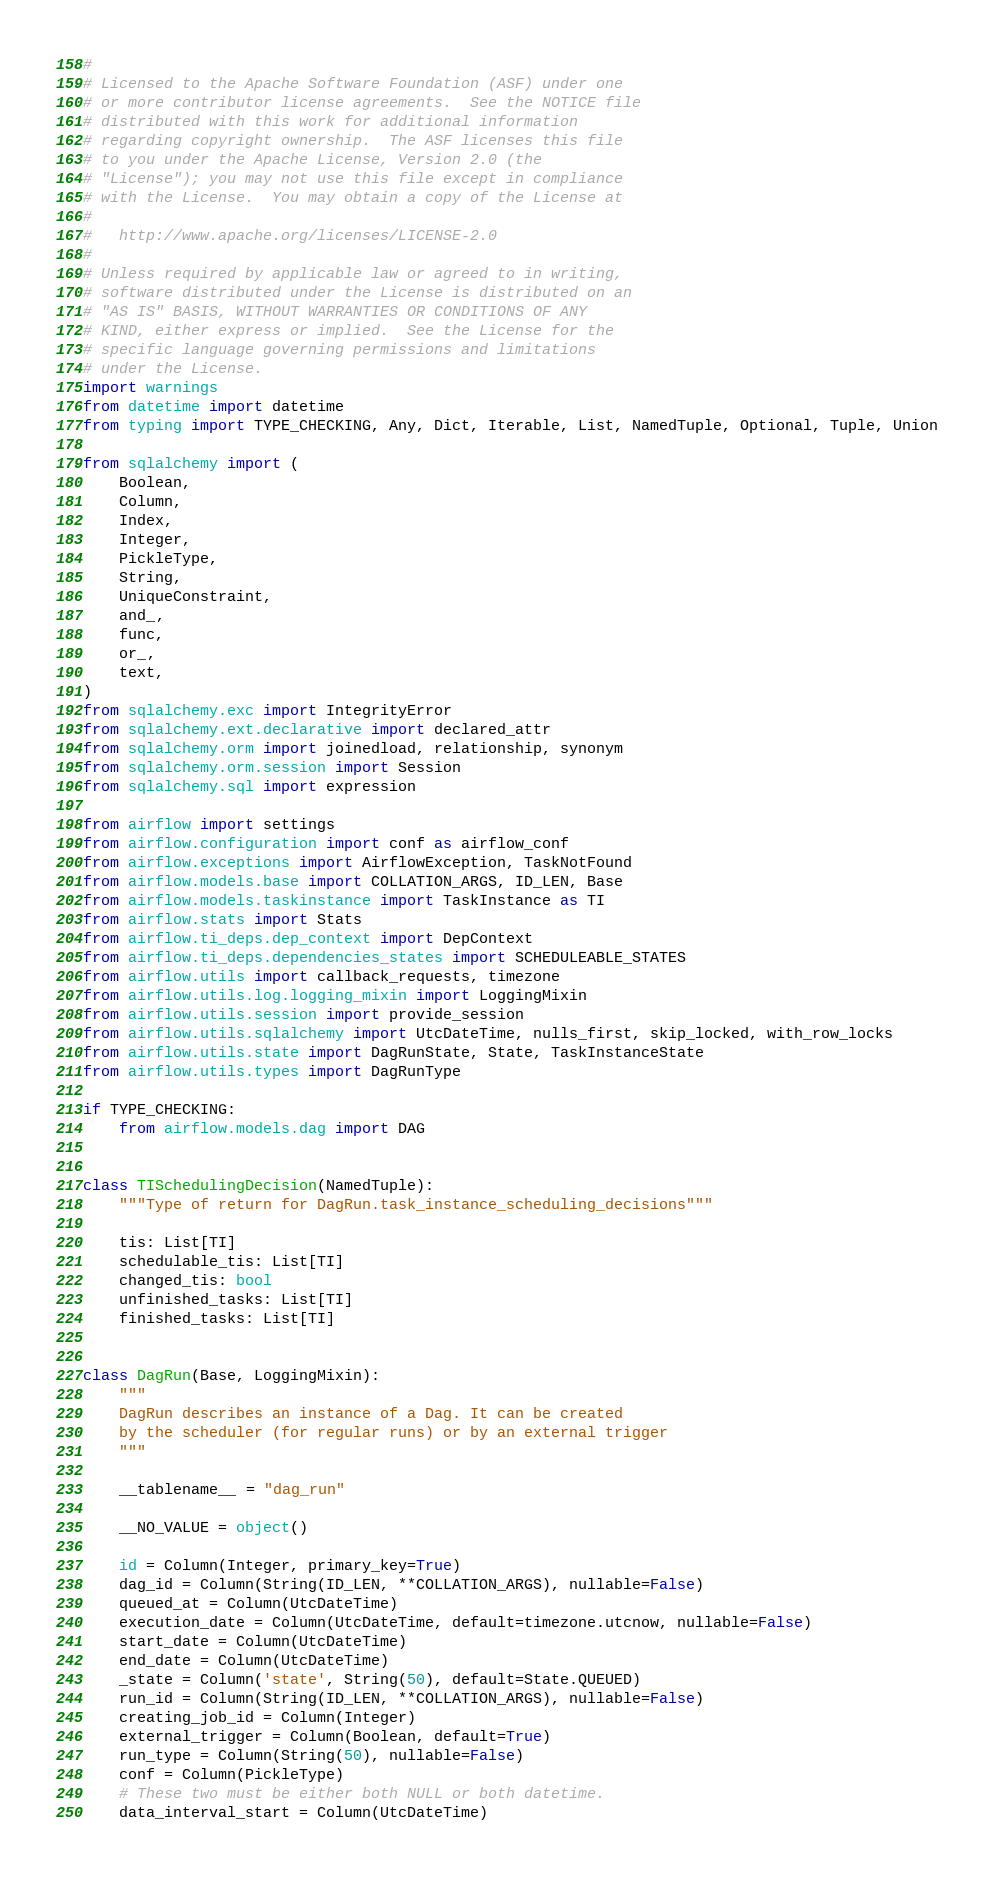Convert code to text. <code><loc_0><loc_0><loc_500><loc_500><_Python_>#
# Licensed to the Apache Software Foundation (ASF) under one
# or more contributor license agreements.  See the NOTICE file
# distributed with this work for additional information
# regarding copyright ownership.  The ASF licenses this file
# to you under the Apache License, Version 2.0 (the
# "License"); you may not use this file except in compliance
# with the License.  You may obtain a copy of the License at
#
#   http://www.apache.org/licenses/LICENSE-2.0
#
# Unless required by applicable law or agreed to in writing,
# software distributed under the License is distributed on an
# "AS IS" BASIS, WITHOUT WARRANTIES OR CONDITIONS OF ANY
# KIND, either express or implied.  See the License for the
# specific language governing permissions and limitations
# under the License.
import warnings
from datetime import datetime
from typing import TYPE_CHECKING, Any, Dict, Iterable, List, NamedTuple, Optional, Tuple, Union

from sqlalchemy import (
    Boolean,
    Column,
    Index,
    Integer,
    PickleType,
    String,
    UniqueConstraint,
    and_,
    func,
    or_,
    text,
)
from sqlalchemy.exc import IntegrityError
from sqlalchemy.ext.declarative import declared_attr
from sqlalchemy.orm import joinedload, relationship, synonym
from sqlalchemy.orm.session import Session
from sqlalchemy.sql import expression

from airflow import settings
from airflow.configuration import conf as airflow_conf
from airflow.exceptions import AirflowException, TaskNotFound
from airflow.models.base import COLLATION_ARGS, ID_LEN, Base
from airflow.models.taskinstance import TaskInstance as TI
from airflow.stats import Stats
from airflow.ti_deps.dep_context import DepContext
from airflow.ti_deps.dependencies_states import SCHEDULEABLE_STATES
from airflow.utils import callback_requests, timezone
from airflow.utils.log.logging_mixin import LoggingMixin
from airflow.utils.session import provide_session
from airflow.utils.sqlalchemy import UtcDateTime, nulls_first, skip_locked, with_row_locks
from airflow.utils.state import DagRunState, State, TaskInstanceState
from airflow.utils.types import DagRunType

if TYPE_CHECKING:
    from airflow.models.dag import DAG


class TISchedulingDecision(NamedTuple):
    """Type of return for DagRun.task_instance_scheduling_decisions"""

    tis: List[TI]
    schedulable_tis: List[TI]
    changed_tis: bool
    unfinished_tasks: List[TI]
    finished_tasks: List[TI]


class DagRun(Base, LoggingMixin):
    """
    DagRun describes an instance of a Dag. It can be created
    by the scheduler (for regular runs) or by an external trigger
    """

    __tablename__ = "dag_run"

    __NO_VALUE = object()

    id = Column(Integer, primary_key=True)
    dag_id = Column(String(ID_LEN, **COLLATION_ARGS), nullable=False)
    queued_at = Column(UtcDateTime)
    execution_date = Column(UtcDateTime, default=timezone.utcnow, nullable=False)
    start_date = Column(UtcDateTime)
    end_date = Column(UtcDateTime)
    _state = Column('state', String(50), default=State.QUEUED)
    run_id = Column(String(ID_LEN, **COLLATION_ARGS), nullable=False)
    creating_job_id = Column(Integer)
    external_trigger = Column(Boolean, default=True)
    run_type = Column(String(50), nullable=False)
    conf = Column(PickleType)
    # These two must be either both NULL or both datetime.
    data_interval_start = Column(UtcDateTime)</code> 